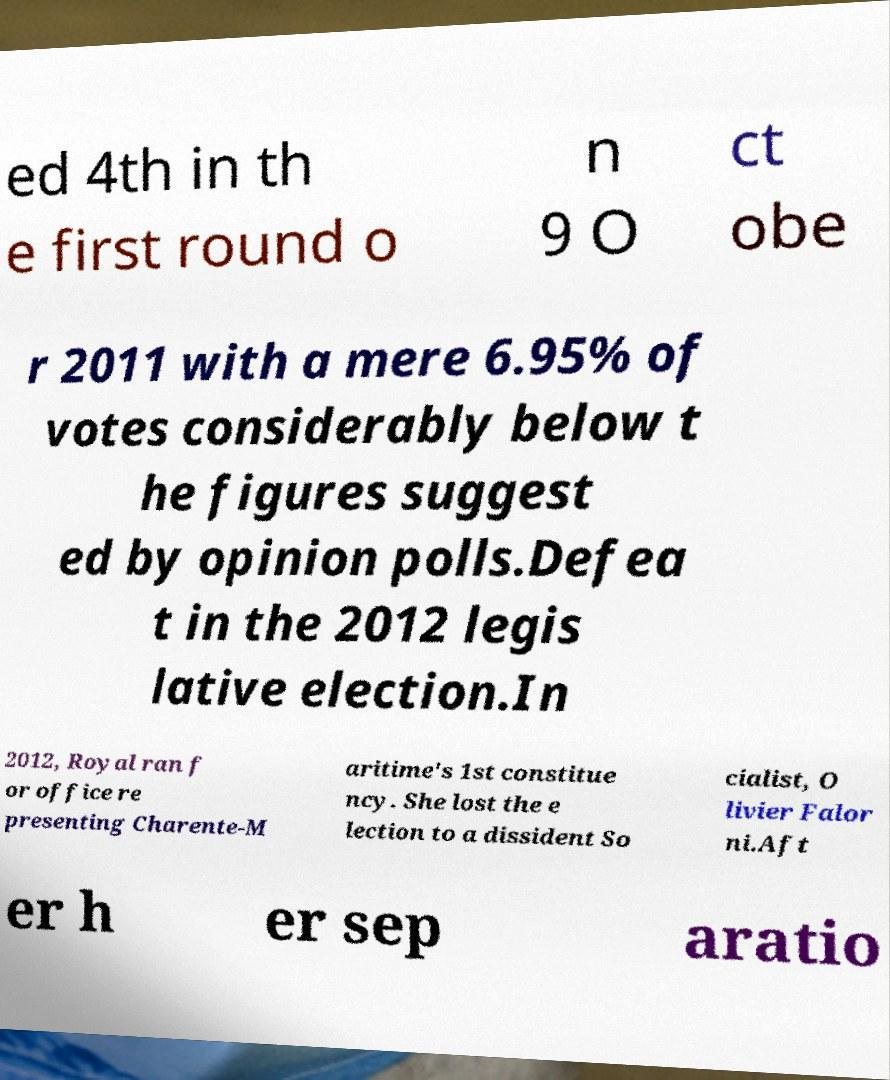I need the written content from this picture converted into text. Can you do that? ed 4th in th e first round o n 9 O ct obe r 2011 with a mere 6.95% of votes considerably below t he figures suggest ed by opinion polls.Defea t in the 2012 legis lative election.In 2012, Royal ran f or office re presenting Charente-M aritime's 1st constitue ncy. She lost the e lection to a dissident So cialist, O livier Falor ni.Aft er h er sep aratio 